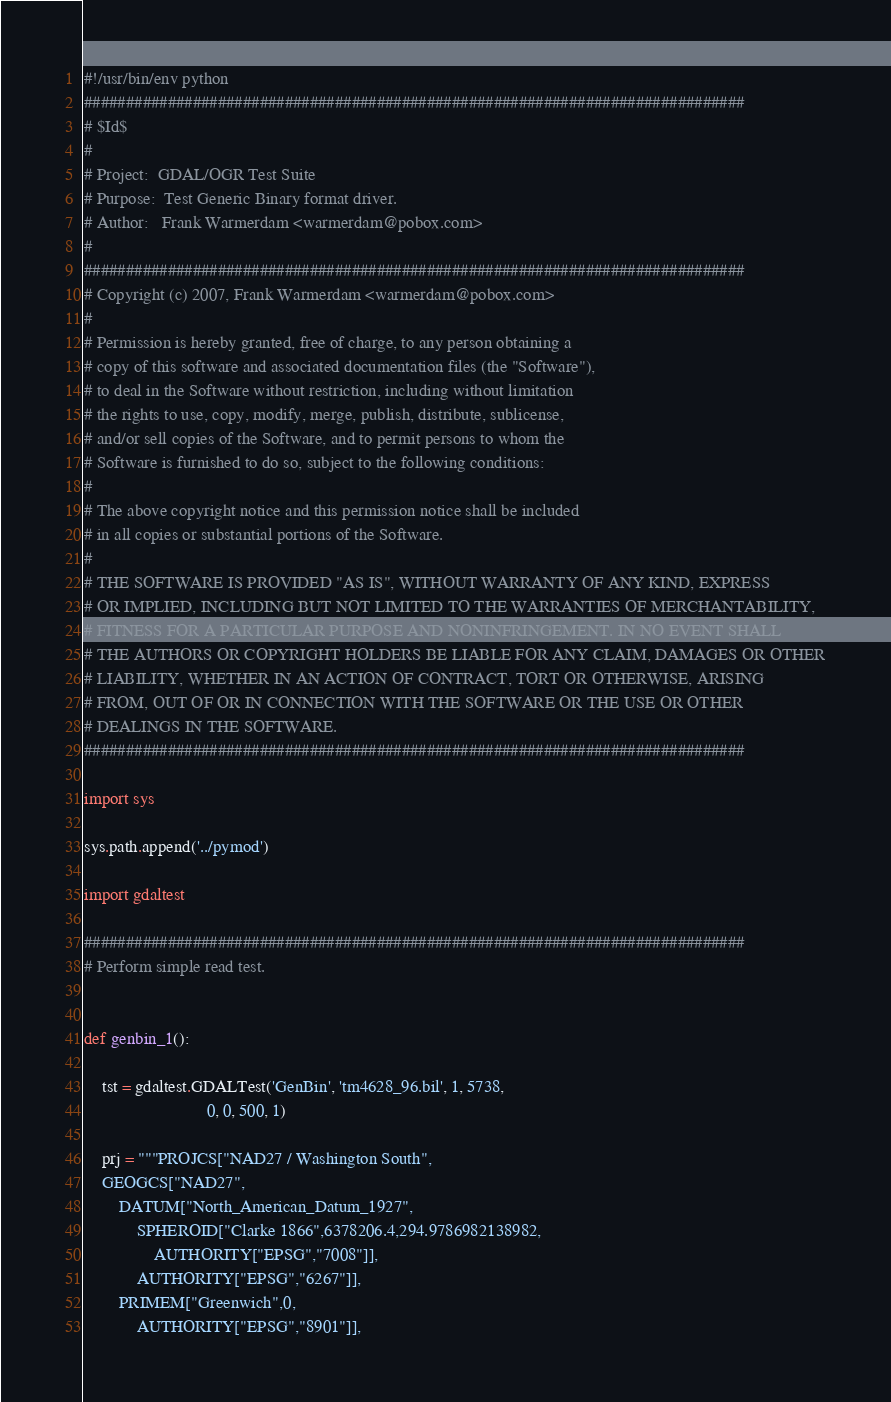<code> <loc_0><loc_0><loc_500><loc_500><_Python_>#!/usr/bin/env python
###############################################################################
# $Id$
#
# Project:  GDAL/OGR Test Suite
# Purpose:  Test Generic Binary format driver.
# Author:   Frank Warmerdam <warmerdam@pobox.com>
#
###############################################################################
# Copyright (c) 2007, Frank Warmerdam <warmerdam@pobox.com>
#
# Permission is hereby granted, free of charge, to any person obtaining a
# copy of this software and associated documentation files (the "Software"),
# to deal in the Software without restriction, including without limitation
# the rights to use, copy, modify, merge, publish, distribute, sublicense,
# and/or sell copies of the Software, and to permit persons to whom the
# Software is furnished to do so, subject to the following conditions:
#
# The above copyright notice and this permission notice shall be included
# in all copies or substantial portions of the Software.
#
# THE SOFTWARE IS PROVIDED "AS IS", WITHOUT WARRANTY OF ANY KIND, EXPRESS
# OR IMPLIED, INCLUDING BUT NOT LIMITED TO THE WARRANTIES OF MERCHANTABILITY,
# FITNESS FOR A PARTICULAR PURPOSE AND NONINFRINGEMENT. IN NO EVENT SHALL
# THE AUTHORS OR COPYRIGHT HOLDERS BE LIABLE FOR ANY CLAIM, DAMAGES OR OTHER
# LIABILITY, WHETHER IN AN ACTION OF CONTRACT, TORT OR OTHERWISE, ARISING
# FROM, OUT OF OR IN CONNECTION WITH THE SOFTWARE OR THE USE OR OTHER
# DEALINGS IN THE SOFTWARE.
###############################################################################

import sys

sys.path.append('../pymod')

import gdaltest

###############################################################################
# Perform simple read test.


def genbin_1():

    tst = gdaltest.GDALTest('GenBin', 'tm4628_96.bil', 1, 5738,
                            0, 0, 500, 1)

    prj = """PROJCS["NAD27 / Washington South",
    GEOGCS["NAD27",
        DATUM["North_American_Datum_1927",
            SPHEROID["Clarke 1866",6378206.4,294.9786982138982,
                AUTHORITY["EPSG","7008"]],
            AUTHORITY["EPSG","6267"]],
        PRIMEM["Greenwich",0,
            AUTHORITY["EPSG","8901"]],</code> 